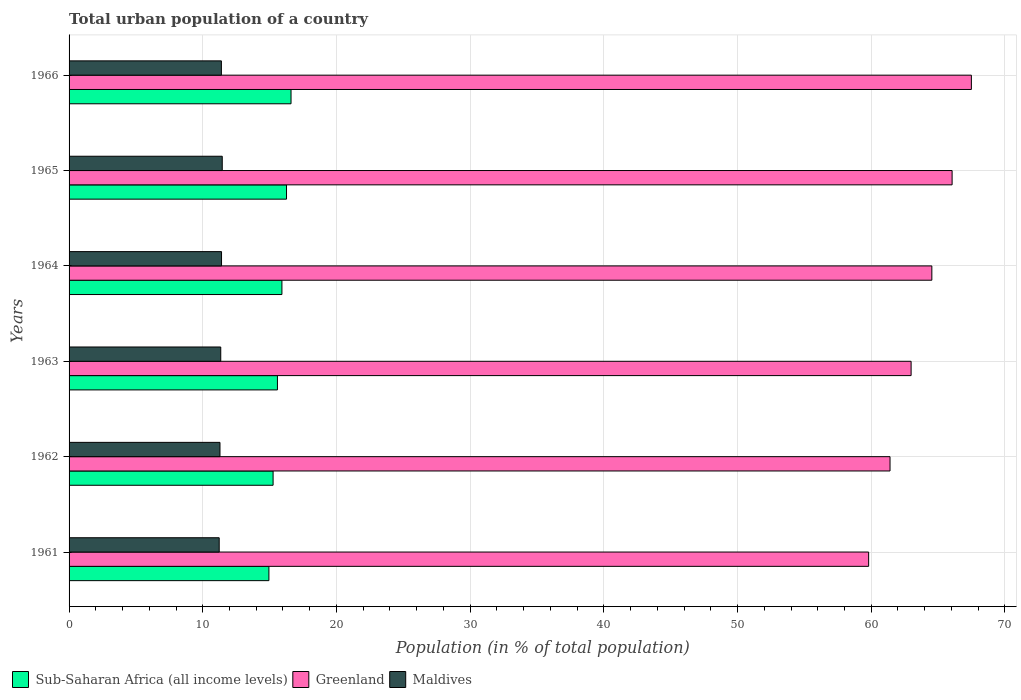How many groups of bars are there?
Your answer should be compact. 6. Are the number of bars on each tick of the Y-axis equal?
Provide a short and direct response. Yes. What is the urban population in Maldives in 1961?
Make the answer very short. 11.23. Across all years, what is the maximum urban population in Sub-Saharan Africa (all income levels)?
Your answer should be very brief. 16.6. Across all years, what is the minimum urban population in Maldives?
Provide a short and direct response. 11.23. In which year was the urban population in Greenland maximum?
Ensure brevity in your answer.  1966. What is the total urban population in Greenland in the graph?
Provide a succinct answer. 382.27. What is the difference between the urban population in Sub-Saharan Africa (all income levels) in 1961 and that in 1965?
Offer a very short reply. -1.32. What is the difference between the urban population in Sub-Saharan Africa (all income levels) in 1965 and the urban population in Maldives in 1963?
Keep it short and to the point. 4.92. What is the average urban population in Sub-Saharan Africa (all income levels) per year?
Offer a terse response. 15.76. In the year 1962, what is the difference between the urban population in Maldives and urban population in Sub-Saharan Africa (all income levels)?
Make the answer very short. -3.97. What is the ratio of the urban population in Greenland in 1962 to that in 1965?
Keep it short and to the point. 0.93. Is the urban population in Maldives in 1962 less than that in 1963?
Give a very brief answer. Yes. Is the difference between the urban population in Maldives in 1962 and 1966 greater than the difference between the urban population in Sub-Saharan Africa (all income levels) in 1962 and 1966?
Offer a very short reply. Yes. What is the difference between the highest and the second highest urban population in Greenland?
Provide a short and direct response. 1.44. What is the difference between the highest and the lowest urban population in Sub-Saharan Africa (all income levels)?
Give a very brief answer. 1.66. In how many years, is the urban population in Maldives greater than the average urban population in Maldives taken over all years?
Provide a succinct answer. 3. Is the sum of the urban population in Greenland in 1961 and 1962 greater than the maximum urban population in Maldives across all years?
Your answer should be compact. Yes. What does the 1st bar from the top in 1963 represents?
Your response must be concise. Maldives. What does the 2nd bar from the bottom in 1964 represents?
Make the answer very short. Greenland. Is it the case that in every year, the sum of the urban population in Greenland and urban population in Maldives is greater than the urban population in Sub-Saharan Africa (all income levels)?
Your answer should be very brief. Yes. How many bars are there?
Your response must be concise. 18. How are the legend labels stacked?
Give a very brief answer. Horizontal. What is the title of the graph?
Provide a short and direct response. Total urban population of a country. What is the label or title of the X-axis?
Provide a succinct answer. Population (in % of total population). What is the label or title of the Y-axis?
Offer a very short reply. Years. What is the Population (in % of total population) of Sub-Saharan Africa (all income levels) in 1961?
Ensure brevity in your answer.  14.95. What is the Population (in % of total population) in Greenland in 1961?
Offer a very short reply. 59.81. What is the Population (in % of total population) in Maldives in 1961?
Your response must be concise. 11.23. What is the Population (in % of total population) in Sub-Saharan Africa (all income levels) in 1962?
Make the answer very short. 15.26. What is the Population (in % of total population) in Greenland in 1962?
Provide a short and direct response. 61.41. What is the Population (in % of total population) in Maldives in 1962?
Provide a succinct answer. 11.29. What is the Population (in % of total population) in Sub-Saharan Africa (all income levels) in 1963?
Your answer should be very brief. 15.59. What is the Population (in % of total population) in Greenland in 1963?
Give a very brief answer. 62.98. What is the Population (in % of total population) of Maldives in 1963?
Offer a terse response. 11.35. What is the Population (in % of total population) of Sub-Saharan Africa (all income levels) in 1964?
Your response must be concise. 15.92. What is the Population (in % of total population) in Greenland in 1964?
Your answer should be compact. 64.53. What is the Population (in % of total population) of Maldives in 1964?
Offer a terse response. 11.4. What is the Population (in % of total population) of Sub-Saharan Africa (all income levels) in 1965?
Give a very brief answer. 16.26. What is the Population (in % of total population) in Greenland in 1965?
Your answer should be compact. 66.05. What is the Population (in % of total population) in Maldives in 1965?
Offer a terse response. 11.46. What is the Population (in % of total population) of Sub-Saharan Africa (all income levels) in 1966?
Your answer should be very brief. 16.6. What is the Population (in % of total population) of Greenland in 1966?
Your answer should be very brief. 67.49. What is the Population (in % of total population) of Maldives in 1966?
Keep it short and to the point. 11.39. Across all years, what is the maximum Population (in % of total population) of Sub-Saharan Africa (all income levels)?
Provide a succinct answer. 16.6. Across all years, what is the maximum Population (in % of total population) of Greenland?
Provide a succinct answer. 67.49. Across all years, what is the maximum Population (in % of total population) of Maldives?
Provide a succinct answer. 11.46. Across all years, what is the minimum Population (in % of total population) in Sub-Saharan Africa (all income levels)?
Provide a short and direct response. 14.95. Across all years, what is the minimum Population (in % of total population) in Greenland?
Ensure brevity in your answer.  59.81. Across all years, what is the minimum Population (in % of total population) in Maldives?
Your answer should be compact. 11.23. What is the total Population (in % of total population) in Sub-Saharan Africa (all income levels) in the graph?
Your answer should be compact. 94.58. What is the total Population (in % of total population) of Greenland in the graph?
Your answer should be compact. 382.27. What is the total Population (in % of total population) in Maldives in the graph?
Your answer should be compact. 68.12. What is the difference between the Population (in % of total population) of Sub-Saharan Africa (all income levels) in 1961 and that in 1962?
Offer a very short reply. -0.31. What is the difference between the Population (in % of total population) of Maldives in 1961 and that in 1962?
Your answer should be very brief. -0.06. What is the difference between the Population (in % of total population) in Sub-Saharan Africa (all income levels) in 1961 and that in 1963?
Your response must be concise. -0.64. What is the difference between the Population (in % of total population) of Greenland in 1961 and that in 1963?
Your answer should be very brief. -3.18. What is the difference between the Population (in % of total population) in Maldives in 1961 and that in 1963?
Provide a short and direct response. -0.12. What is the difference between the Population (in % of total population) of Sub-Saharan Africa (all income levels) in 1961 and that in 1964?
Provide a succinct answer. -0.97. What is the difference between the Population (in % of total population) in Greenland in 1961 and that in 1964?
Your answer should be compact. -4.73. What is the difference between the Population (in % of total population) in Maldives in 1961 and that in 1964?
Provide a succinct answer. -0.17. What is the difference between the Population (in % of total population) in Sub-Saharan Africa (all income levels) in 1961 and that in 1965?
Your response must be concise. -1.32. What is the difference between the Population (in % of total population) in Greenland in 1961 and that in 1965?
Your answer should be very brief. -6.24. What is the difference between the Population (in % of total population) of Maldives in 1961 and that in 1965?
Provide a succinct answer. -0.23. What is the difference between the Population (in % of total population) of Sub-Saharan Africa (all income levels) in 1961 and that in 1966?
Ensure brevity in your answer.  -1.66. What is the difference between the Population (in % of total population) in Greenland in 1961 and that in 1966?
Ensure brevity in your answer.  -7.68. What is the difference between the Population (in % of total population) of Maldives in 1961 and that in 1966?
Keep it short and to the point. -0.16. What is the difference between the Population (in % of total population) in Sub-Saharan Africa (all income levels) in 1962 and that in 1963?
Provide a succinct answer. -0.33. What is the difference between the Population (in % of total population) in Greenland in 1962 and that in 1963?
Ensure brevity in your answer.  -1.58. What is the difference between the Population (in % of total population) of Maldives in 1962 and that in 1963?
Your response must be concise. -0.06. What is the difference between the Population (in % of total population) in Sub-Saharan Africa (all income levels) in 1962 and that in 1964?
Ensure brevity in your answer.  -0.66. What is the difference between the Population (in % of total population) of Greenland in 1962 and that in 1964?
Provide a short and direct response. -3.13. What is the difference between the Population (in % of total population) of Maldives in 1962 and that in 1964?
Make the answer very short. -0.12. What is the difference between the Population (in % of total population) in Sub-Saharan Africa (all income levels) in 1962 and that in 1965?
Offer a terse response. -1. What is the difference between the Population (in % of total population) in Greenland in 1962 and that in 1965?
Make the answer very short. -4.64. What is the difference between the Population (in % of total population) in Maldives in 1962 and that in 1965?
Provide a short and direct response. -0.17. What is the difference between the Population (in % of total population) in Sub-Saharan Africa (all income levels) in 1962 and that in 1966?
Offer a very short reply. -1.34. What is the difference between the Population (in % of total population) in Greenland in 1962 and that in 1966?
Ensure brevity in your answer.  -6.08. What is the difference between the Population (in % of total population) in Maldives in 1962 and that in 1966?
Give a very brief answer. -0.1. What is the difference between the Population (in % of total population) of Sub-Saharan Africa (all income levels) in 1963 and that in 1964?
Your response must be concise. -0.34. What is the difference between the Population (in % of total population) in Greenland in 1963 and that in 1964?
Ensure brevity in your answer.  -1.55. What is the difference between the Population (in % of total population) of Maldives in 1963 and that in 1964?
Offer a very short reply. -0.06. What is the difference between the Population (in % of total population) of Sub-Saharan Africa (all income levels) in 1963 and that in 1965?
Your answer should be compact. -0.68. What is the difference between the Population (in % of total population) of Greenland in 1963 and that in 1965?
Your answer should be compact. -3.07. What is the difference between the Population (in % of total population) in Maldives in 1963 and that in 1965?
Keep it short and to the point. -0.11. What is the difference between the Population (in % of total population) of Sub-Saharan Africa (all income levels) in 1963 and that in 1966?
Your answer should be compact. -1.02. What is the difference between the Population (in % of total population) of Greenland in 1963 and that in 1966?
Provide a succinct answer. -4.51. What is the difference between the Population (in % of total population) in Maldives in 1963 and that in 1966?
Your response must be concise. -0.05. What is the difference between the Population (in % of total population) in Sub-Saharan Africa (all income levels) in 1964 and that in 1965?
Offer a terse response. -0.34. What is the difference between the Population (in % of total population) in Greenland in 1964 and that in 1965?
Your response must be concise. -1.52. What is the difference between the Population (in % of total population) of Maldives in 1964 and that in 1965?
Give a very brief answer. -0.05. What is the difference between the Population (in % of total population) of Sub-Saharan Africa (all income levels) in 1964 and that in 1966?
Provide a short and direct response. -0.68. What is the difference between the Population (in % of total population) in Greenland in 1964 and that in 1966?
Your answer should be very brief. -2.96. What is the difference between the Population (in % of total population) of Maldives in 1964 and that in 1966?
Your answer should be compact. 0.01. What is the difference between the Population (in % of total population) of Sub-Saharan Africa (all income levels) in 1965 and that in 1966?
Provide a short and direct response. -0.34. What is the difference between the Population (in % of total population) in Greenland in 1965 and that in 1966?
Give a very brief answer. -1.44. What is the difference between the Population (in % of total population) of Maldives in 1965 and that in 1966?
Offer a very short reply. 0.07. What is the difference between the Population (in % of total population) in Sub-Saharan Africa (all income levels) in 1961 and the Population (in % of total population) in Greenland in 1962?
Offer a very short reply. -46.46. What is the difference between the Population (in % of total population) in Sub-Saharan Africa (all income levels) in 1961 and the Population (in % of total population) in Maldives in 1962?
Offer a very short reply. 3.66. What is the difference between the Population (in % of total population) of Greenland in 1961 and the Population (in % of total population) of Maldives in 1962?
Provide a succinct answer. 48.52. What is the difference between the Population (in % of total population) in Sub-Saharan Africa (all income levels) in 1961 and the Population (in % of total population) in Greenland in 1963?
Your answer should be very brief. -48.04. What is the difference between the Population (in % of total population) in Sub-Saharan Africa (all income levels) in 1961 and the Population (in % of total population) in Maldives in 1963?
Provide a short and direct response. 3.6. What is the difference between the Population (in % of total population) of Greenland in 1961 and the Population (in % of total population) of Maldives in 1963?
Keep it short and to the point. 48.46. What is the difference between the Population (in % of total population) in Sub-Saharan Africa (all income levels) in 1961 and the Population (in % of total population) in Greenland in 1964?
Offer a terse response. -49.59. What is the difference between the Population (in % of total population) in Sub-Saharan Africa (all income levels) in 1961 and the Population (in % of total population) in Maldives in 1964?
Make the answer very short. 3.54. What is the difference between the Population (in % of total population) in Greenland in 1961 and the Population (in % of total population) in Maldives in 1964?
Provide a short and direct response. 48.4. What is the difference between the Population (in % of total population) of Sub-Saharan Africa (all income levels) in 1961 and the Population (in % of total population) of Greenland in 1965?
Provide a short and direct response. -51.1. What is the difference between the Population (in % of total population) of Sub-Saharan Africa (all income levels) in 1961 and the Population (in % of total population) of Maldives in 1965?
Keep it short and to the point. 3.49. What is the difference between the Population (in % of total population) of Greenland in 1961 and the Population (in % of total population) of Maldives in 1965?
Ensure brevity in your answer.  48.35. What is the difference between the Population (in % of total population) in Sub-Saharan Africa (all income levels) in 1961 and the Population (in % of total population) in Greenland in 1966?
Give a very brief answer. -52.54. What is the difference between the Population (in % of total population) of Sub-Saharan Africa (all income levels) in 1961 and the Population (in % of total population) of Maldives in 1966?
Make the answer very short. 3.55. What is the difference between the Population (in % of total population) in Greenland in 1961 and the Population (in % of total population) in Maldives in 1966?
Ensure brevity in your answer.  48.41. What is the difference between the Population (in % of total population) of Sub-Saharan Africa (all income levels) in 1962 and the Population (in % of total population) of Greenland in 1963?
Offer a very short reply. -47.72. What is the difference between the Population (in % of total population) in Sub-Saharan Africa (all income levels) in 1962 and the Population (in % of total population) in Maldives in 1963?
Your response must be concise. 3.92. What is the difference between the Population (in % of total population) in Greenland in 1962 and the Population (in % of total population) in Maldives in 1963?
Keep it short and to the point. 50.06. What is the difference between the Population (in % of total population) in Sub-Saharan Africa (all income levels) in 1962 and the Population (in % of total population) in Greenland in 1964?
Your answer should be compact. -49.27. What is the difference between the Population (in % of total population) of Sub-Saharan Africa (all income levels) in 1962 and the Population (in % of total population) of Maldives in 1964?
Give a very brief answer. 3.86. What is the difference between the Population (in % of total population) in Greenland in 1962 and the Population (in % of total population) in Maldives in 1964?
Give a very brief answer. 50. What is the difference between the Population (in % of total population) in Sub-Saharan Africa (all income levels) in 1962 and the Population (in % of total population) in Greenland in 1965?
Make the answer very short. -50.79. What is the difference between the Population (in % of total population) of Sub-Saharan Africa (all income levels) in 1962 and the Population (in % of total population) of Maldives in 1965?
Your answer should be very brief. 3.8. What is the difference between the Population (in % of total population) in Greenland in 1962 and the Population (in % of total population) in Maldives in 1965?
Keep it short and to the point. 49.95. What is the difference between the Population (in % of total population) in Sub-Saharan Africa (all income levels) in 1962 and the Population (in % of total population) in Greenland in 1966?
Your response must be concise. -52.23. What is the difference between the Population (in % of total population) in Sub-Saharan Africa (all income levels) in 1962 and the Population (in % of total population) in Maldives in 1966?
Your answer should be very brief. 3.87. What is the difference between the Population (in % of total population) in Greenland in 1962 and the Population (in % of total population) in Maldives in 1966?
Provide a succinct answer. 50.01. What is the difference between the Population (in % of total population) in Sub-Saharan Africa (all income levels) in 1963 and the Population (in % of total population) in Greenland in 1964?
Keep it short and to the point. -48.95. What is the difference between the Population (in % of total population) of Sub-Saharan Africa (all income levels) in 1963 and the Population (in % of total population) of Maldives in 1964?
Give a very brief answer. 4.18. What is the difference between the Population (in % of total population) in Greenland in 1963 and the Population (in % of total population) in Maldives in 1964?
Provide a succinct answer. 51.58. What is the difference between the Population (in % of total population) in Sub-Saharan Africa (all income levels) in 1963 and the Population (in % of total population) in Greenland in 1965?
Offer a very short reply. -50.46. What is the difference between the Population (in % of total population) in Sub-Saharan Africa (all income levels) in 1963 and the Population (in % of total population) in Maldives in 1965?
Your answer should be very brief. 4.13. What is the difference between the Population (in % of total population) in Greenland in 1963 and the Population (in % of total population) in Maldives in 1965?
Provide a short and direct response. 51.52. What is the difference between the Population (in % of total population) in Sub-Saharan Africa (all income levels) in 1963 and the Population (in % of total population) in Greenland in 1966?
Make the answer very short. -51.91. What is the difference between the Population (in % of total population) of Sub-Saharan Africa (all income levels) in 1963 and the Population (in % of total population) of Maldives in 1966?
Provide a succinct answer. 4.19. What is the difference between the Population (in % of total population) in Greenland in 1963 and the Population (in % of total population) in Maldives in 1966?
Offer a terse response. 51.59. What is the difference between the Population (in % of total population) in Sub-Saharan Africa (all income levels) in 1964 and the Population (in % of total population) in Greenland in 1965?
Give a very brief answer. -50.13. What is the difference between the Population (in % of total population) of Sub-Saharan Africa (all income levels) in 1964 and the Population (in % of total population) of Maldives in 1965?
Give a very brief answer. 4.46. What is the difference between the Population (in % of total population) in Greenland in 1964 and the Population (in % of total population) in Maldives in 1965?
Offer a very short reply. 53.08. What is the difference between the Population (in % of total population) of Sub-Saharan Africa (all income levels) in 1964 and the Population (in % of total population) of Greenland in 1966?
Offer a very short reply. -51.57. What is the difference between the Population (in % of total population) of Sub-Saharan Africa (all income levels) in 1964 and the Population (in % of total population) of Maldives in 1966?
Give a very brief answer. 4.53. What is the difference between the Population (in % of total population) of Greenland in 1964 and the Population (in % of total population) of Maldives in 1966?
Ensure brevity in your answer.  53.14. What is the difference between the Population (in % of total population) in Sub-Saharan Africa (all income levels) in 1965 and the Population (in % of total population) in Greenland in 1966?
Make the answer very short. -51.23. What is the difference between the Population (in % of total population) of Sub-Saharan Africa (all income levels) in 1965 and the Population (in % of total population) of Maldives in 1966?
Keep it short and to the point. 4.87. What is the difference between the Population (in % of total population) of Greenland in 1965 and the Population (in % of total population) of Maldives in 1966?
Your answer should be very brief. 54.66. What is the average Population (in % of total population) in Sub-Saharan Africa (all income levels) per year?
Give a very brief answer. 15.76. What is the average Population (in % of total population) in Greenland per year?
Your response must be concise. 63.71. What is the average Population (in % of total population) of Maldives per year?
Provide a short and direct response. 11.35. In the year 1961, what is the difference between the Population (in % of total population) in Sub-Saharan Africa (all income levels) and Population (in % of total population) in Greenland?
Offer a terse response. -44.86. In the year 1961, what is the difference between the Population (in % of total population) of Sub-Saharan Africa (all income levels) and Population (in % of total population) of Maldives?
Keep it short and to the point. 3.72. In the year 1961, what is the difference between the Population (in % of total population) of Greenland and Population (in % of total population) of Maldives?
Give a very brief answer. 48.58. In the year 1962, what is the difference between the Population (in % of total population) of Sub-Saharan Africa (all income levels) and Population (in % of total population) of Greenland?
Your response must be concise. -46.15. In the year 1962, what is the difference between the Population (in % of total population) in Sub-Saharan Africa (all income levels) and Population (in % of total population) in Maldives?
Offer a terse response. 3.97. In the year 1962, what is the difference between the Population (in % of total population) of Greenland and Population (in % of total population) of Maldives?
Offer a terse response. 50.12. In the year 1963, what is the difference between the Population (in % of total population) in Sub-Saharan Africa (all income levels) and Population (in % of total population) in Greenland?
Provide a succinct answer. -47.4. In the year 1963, what is the difference between the Population (in % of total population) in Sub-Saharan Africa (all income levels) and Population (in % of total population) in Maldives?
Your answer should be very brief. 4.24. In the year 1963, what is the difference between the Population (in % of total population) in Greenland and Population (in % of total population) in Maldives?
Your answer should be compact. 51.64. In the year 1964, what is the difference between the Population (in % of total population) of Sub-Saharan Africa (all income levels) and Population (in % of total population) of Greenland?
Your response must be concise. -48.61. In the year 1964, what is the difference between the Population (in % of total population) in Sub-Saharan Africa (all income levels) and Population (in % of total population) in Maldives?
Your answer should be very brief. 4.52. In the year 1964, what is the difference between the Population (in % of total population) of Greenland and Population (in % of total population) of Maldives?
Provide a succinct answer. 53.13. In the year 1965, what is the difference between the Population (in % of total population) in Sub-Saharan Africa (all income levels) and Population (in % of total population) in Greenland?
Your answer should be compact. -49.79. In the year 1965, what is the difference between the Population (in % of total population) of Sub-Saharan Africa (all income levels) and Population (in % of total population) of Maldives?
Give a very brief answer. 4.81. In the year 1965, what is the difference between the Population (in % of total population) in Greenland and Population (in % of total population) in Maldives?
Provide a short and direct response. 54.59. In the year 1966, what is the difference between the Population (in % of total population) in Sub-Saharan Africa (all income levels) and Population (in % of total population) in Greenland?
Provide a succinct answer. -50.89. In the year 1966, what is the difference between the Population (in % of total population) in Sub-Saharan Africa (all income levels) and Population (in % of total population) in Maldives?
Keep it short and to the point. 5.21. In the year 1966, what is the difference between the Population (in % of total population) in Greenland and Population (in % of total population) in Maldives?
Offer a terse response. 56.1. What is the ratio of the Population (in % of total population) in Sub-Saharan Africa (all income levels) in 1961 to that in 1962?
Offer a very short reply. 0.98. What is the ratio of the Population (in % of total population) in Greenland in 1961 to that in 1962?
Give a very brief answer. 0.97. What is the ratio of the Population (in % of total population) in Maldives in 1961 to that in 1962?
Provide a succinct answer. 0.99. What is the ratio of the Population (in % of total population) in Sub-Saharan Africa (all income levels) in 1961 to that in 1963?
Offer a very short reply. 0.96. What is the ratio of the Population (in % of total population) of Greenland in 1961 to that in 1963?
Ensure brevity in your answer.  0.95. What is the ratio of the Population (in % of total population) of Maldives in 1961 to that in 1963?
Your answer should be very brief. 0.99. What is the ratio of the Population (in % of total population) in Sub-Saharan Africa (all income levels) in 1961 to that in 1964?
Your answer should be very brief. 0.94. What is the ratio of the Population (in % of total population) of Greenland in 1961 to that in 1964?
Your answer should be very brief. 0.93. What is the ratio of the Population (in % of total population) of Maldives in 1961 to that in 1964?
Your answer should be very brief. 0.98. What is the ratio of the Population (in % of total population) in Sub-Saharan Africa (all income levels) in 1961 to that in 1965?
Your response must be concise. 0.92. What is the ratio of the Population (in % of total population) of Greenland in 1961 to that in 1965?
Keep it short and to the point. 0.91. What is the ratio of the Population (in % of total population) in Maldives in 1961 to that in 1965?
Ensure brevity in your answer.  0.98. What is the ratio of the Population (in % of total population) in Sub-Saharan Africa (all income levels) in 1961 to that in 1966?
Make the answer very short. 0.9. What is the ratio of the Population (in % of total population) in Greenland in 1961 to that in 1966?
Offer a terse response. 0.89. What is the ratio of the Population (in % of total population) of Maldives in 1961 to that in 1966?
Ensure brevity in your answer.  0.99. What is the ratio of the Population (in % of total population) of Sub-Saharan Africa (all income levels) in 1962 to that in 1963?
Provide a short and direct response. 0.98. What is the ratio of the Population (in % of total population) of Greenland in 1962 to that in 1963?
Your answer should be compact. 0.97. What is the ratio of the Population (in % of total population) of Maldives in 1962 to that in 1963?
Offer a very short reply. 0.99. What is the ratio of the Population (in % of total population) in Sub-Saharan Africa (all income levels) in 1962 to that in 1964?
Make the answer very short. 0.96. What is the ratio of the Population (in % of total population) in Greenland in 1962 to that in 1964?
Give a very brief answer. 0.95. What is the ratio of the Population (in % of total population) in Sub-Saharan Africa (all income levels) in 1962 to that in 1965?
Offer a very short reply. 0.94. What is the ratio of the Population (in % of total population) of Greenland in 1962 to that in 1965?
Offer a very short reply. 0.93. What is the ratio of the Population (in % of total population) of Maldives in 1962 to that in 1965?
Provide a succinct answer. 0.99. What is the ratio of the Population (in % of total population) in Sub-Saharan Africa (all income levels) in 1962 to that in 1966?
Your answer should be very brief. 0.92. What is the ratio of the Population (in % of total population) of Greenland in 1962 to that in 1966?
Make the answer very short. 0.91. What is the ratio of the Population (in % of total population) of Sub-Saharan Africa (all income levels) in 1963 to that in 1964?
Make the answer very short. 0.98. What is the ratio of the Population (in % of total population) in Sub-Saharan Africa (all income levels) in 1963 to that in 1965?
Your response must be concise. 0.96. What is the ratio of the Population (in % of total population) of Greenland in 1963 to that in 1965?
Offer a very short reply. 0.95. What is the ratio of the Population (in % of total population) in Sub-Saharan Africa (all income levels) in 1963 to that in 1966?
Provide a succinct answer. 0.94. What is the ratio of the Population (in % of total population) in Greenland in 1963 to that in 1966?
Offer a very short reply. 0.93. What is the ratio of the Population (in % of total population) of Sub-Saharan Africa (all income levels) in 1964 to that in 1965?
Give a very brief answer. 0.98. What is the ratio of the Population (in % of total population) of Maldives in 1964 to that in 1965?
Offer a very short reply. 1. What is the ratio of the Population (in % of total population) in Sub-Saharan Africa (all income levels) in 1964 to that in 1966?
Provide a short and direct response. 0.96. What is the ratio of the Population (in % of total population) in Greenland in 1964 to that in 1966?
Offer a very short reply. 0.96. What is the ratio of the Population (in % of total population) of Maldives in 1964 to that in 1966?
Offer a very short reply. 1. What is the ratio of the Population (in % of total population) of Sub-Saharan Africa (all income levels) in 1965 to that in 1966?
Give a very brief answer. 0.98. What is the ratio of the Population (in % of total population) of Greenland in 1965 to that in 1966?
Your answer should be compact. 0.98. What is the difference between the highest and the second highest Population (in % of total population) in Sub-Saharan Africa (all income levels)?
Keep it short and to the point. 0.34. What is the difference between the highest and the second highest Population (in % of total population) of Greenland?
Provide a succinct answer. 1.44. What is the difference between the highest and the second highest Population (in % of total population) in Maldives?
Offer a terse response. 0.05. What is the difference between the highest and the lowest Population (in % of total population) in Sub-Saharan Africa (all income levels)?
Offer a terse response. 1.66. What is the difference between the highest and the lowest Population (in % of total population) in Greenland?
Offer a very short reply. 7.68. What is the difference between the highest and the lowest Population (in % of total population) of Maldives?
Give a very brief answer. 0.23. 